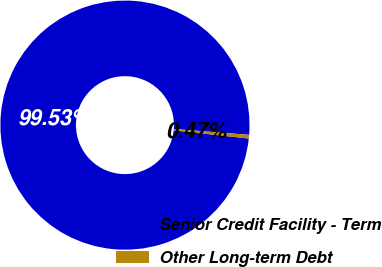Convert chart to OTSL. <chart><loc_0><loc_0><loc_500><loc_500><pie_chart><fcel>Senior Credit Facility - Term<fcel>Other Long-term Debt<nl><fcel>99.53%<fcel>0.47%<nl></chart> 